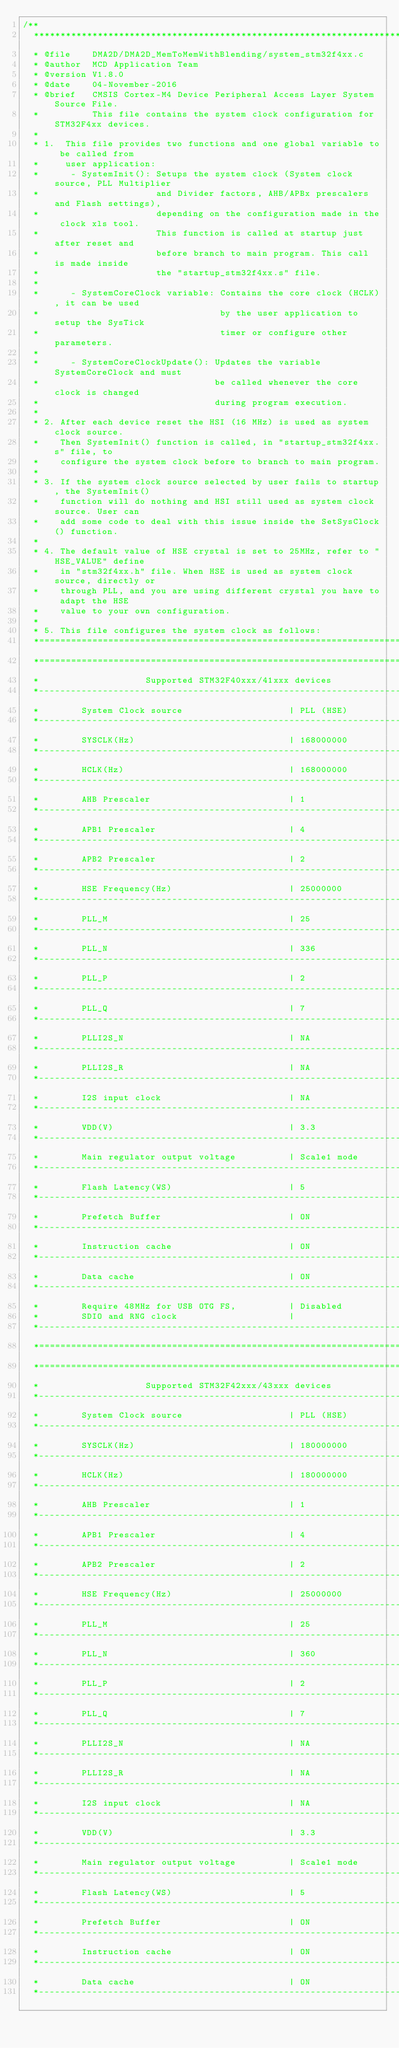<code> <loc_0><loc_0><loc_500><loc_500><_C_>/**
  ******************************************************************************
  * @file    DMA2D/DMA2D_MemToMemWithBlending/system_stm32f4xx.c
  * @author  MCD Application Team
  * @version V1.8.0
  * @date    04-November-2016
  * @brief   CMSIS Cortex-M4 Device Peripheral Access Layer System Source File.
  *          This file contains the system clock configuration for STM32F4xx devices.
  *             
  * 1.  This file provides two functions and one global variable to be called from 
  *     user application:
  *      - SystemInit(): Setups the system clock (System clock source, PLL Multiplier
  *                      and Divider factors, AHB/APBx prescalers and Flash settings),
  *                      depending on the configuration made in the clock xls tool. 
  *                      This function is called at startup just after reset and 
  *                      before branch to main program. This call is made inside
  *                      the "startup_stm32f4xx.s" file.
  *
  *      - SystemCoreClock variable: Contains the core clock (HCLK), it can be used
  *                                  by the user application to setup the SysTick 
  *                                  timer or configure other parameters.
  *                                     
  *      - SystemCoreClockUpdate(): Updates the variable SystemCoreClock and must
  *                                 be called whenever the core clock is changed
  *                                 during program execution.
  *
  * 2. After each device reset the HSI (16 MHz) is used as system clock source.
  *    Then SystemInit() function is called, in "startup_stm32f4xx.s" file, to
  *    configure the system clock before to branch to main program.
  *
  * 3. If the system clock source selected by user fails to startup, the SystemInit()
  *    function will do nothing and HSI still used as system clock source. User can 
  *    add some code to deal with this issue inside the SetSysClock() function.
  *
  * 4. The default value of HSE crystal is set to 25MHz, refer to "HSE_VALUE" define
  *    in "stm32f4xx.h" file. When HSE is used as system clock source, directly or
  *    through PLL, and you are using different crystal you have to adapt the HSE
  *    value to your own configuration.
  *
  * 5. This file configures the system clock as follows:
  *=============================================================================
  *=============================================================================
  *                    Supported STM32F40xxx/41xxx devices
  *-----------------------------------------------------------------------------
  *        System Clock source                    | PLL (HSE)
  *-----------------------------------------------------------------------------
  *        SYSCLK(Hz)                             | 168000000
  *-----------------------------------------------------------------------------
  *        HCLK(Hz)                               | 168000000
  *-----------------------------------------------------------------------------
  *        AHB Prescaler                          | 1
  *-----------------------------------------------------------------------------
  *        APB1 Prescaler                         | 4
  *-----------------------------------------------------------------------------
  *        APB2 Prescaler                         | 2
  *-----------------------------------------------------------------------------
  *        HSE Frequency(Hz)                      | 25000000
  *-----------------------------------------------------------------------------
  *        PLL_M                                  | 25
  *-----------------------------------------------------------------------------
  *        PLL_N                                  | 336
  *-----------------------------------------------------------------------------
  *        PLL_P                                  | 2
  *-----------------------------------------------------------------------------
  *        PLL_Q                                  | 7
  *-----------------------------------------------------------------------------
  *        PLLI2S_N                               | NA
  *-----------------------------------------------------------------------------
  *        PLLI2S_R                               | NA
  *-----------------------------------------------------------------------------
  *        I2S input clock                        | NA
  *-----------------------------------------------------------------------------
  *        VDD(V)                                 | 3.3
  *-----------------------------------------------------------------------------
  *        Main regulator output voltage          | Scale1 mode
  *-----------------------------------------------------------------------------
  *        Flash Latency(WS)                      | 5
  *-----------------------------------------------------------------------------
  *        Prefetch Buffer                        | ON
  *-----------------------------------------------------------------------------
  *        Instruction cache                      | ON
  *-----------------------------------------------------------------------------
  *        Data cache                             | ON
  *-----------------------------------------------------------------------------
  *        Require 48MHz for USB OTG FS,          | Disabled
  *        SDIO and RNG clock                     |
  *-----------------------------------------------------------------------------
  *=============================================================================
  *=============================================================================
  *                    Supported STM32F42xxx/43xxx devices
  *-----------------------------------------------------------------------------
  *        System Clock source                    | PLL (HSE)
  *-----------------------------------------------------------------------------
  *        SYSCLK(Hz)                             | 180000000
  *-----------------------------------------------------------------------------
  *        HCLK(Hz)                               | 180000000
  *-----------------------------------------------------------------------------
  *        AHB Prescaler                          | 1
  *-----------------------------------------------------------------------------
  *        APB1 Prescaler                         | 4
  *-----------------------------------------------------------------------------
  *        APB2 Prescaler                         | 2
  *-----------------------------------------------------------------------------
  *        HSE Frequency(Hz)                      | 25000000
  *-----------------------------------------------------------------------------
  *        PLL_M                                  | 25
  *-----------------------------------------------------------------------------
  *        PLL_N                                  | 360
  *-----------------------------------------------------------------------------
  *        PLL_P                                  | 2
  *-----------------------------------------------------------------------------
  *        PLL_Q                                  | 7
  *-----------------------------------------------------------------------------
  *        PLLI2S_N                               | NA
  *-----------------------------------------------------------------------------
  *        PLLI2S_R                               | NA
  *-----------------------------------------------------------------------------
  *        I2S input clock                        | NA
  *-----------------------------------------------------------------------------
  *        VDD(V)                                 | 3.3
  *-----------------------------------------------------------------------------
  *        Main regulator output voltage          | Scale1 mode
  *-----------------------------------------------------------------------------
  *        Flash Latency(WS)                      | 5
  *-----------------------------------------------------------------------------
  *        Prefetch Buffer                        | ON
  *-----------------------------------------------------------------------------
  *        Instruction cache                      | ON
  *-----------------------------------------------------------------------------
  *        Data cache                             | ON
  *-----------------------------------------------------------------------------</code> 